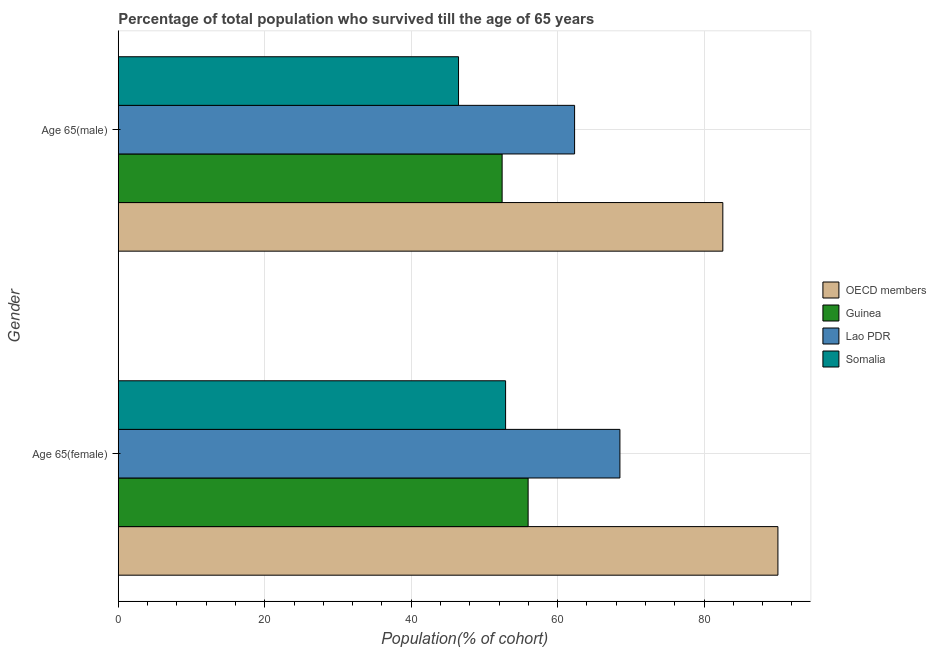How many different coloured bars are there?
Your response must be concise. 4. How many groups of bars are there?
Your response must be concise. 2. How many bars are there on the 2nd tick from the top?
Provide a short and direct response. 4. What is the label of the 2nd group of bars from the top?
Provide a succinct answer. Age 65(female). What is the percentage of male population who survived till age of 65 in Lao PDR?
Provide a succinct answer. 62.32. Across all countries, what is the maximum percentage of female population who survived till age of 65?
Offer a very short reply. 90.08. Across all countries, what is the minimum percentage of male population who survived till age of 65?
Your response must be concise. 46.47. In which country was the percentage of female population who survived till age of 65 maximum?
Offer a very short reply. OECD members. In which country was the percentage of male population who survived till age of 65 minimum?
Your response must be concise. Somalia. What is the total percentage of male population who survived till age of 65 in the graph?
Your response must be concise. 243.76. What is the difference between the percentage of female population who survived till age of 65 in Lao PDR and that in Somalia?
Provide a succinct answer. 15.61. What is the difference between the percentage of female population who survived till age of 65 in Somalia and the percentage of male population who survived till age of 65 in Guinea?
Make the answer very short. 0.47. What is the average percentage of male population who survived till age of 65 per country?
Ensure brevity in your answer.  60.94. What is the difference between the percentage of male population who survived till age of 65 and percentage of female population who survived till age of 65 in Lao PDR?
Your answer should be compact. -6.19. What is the ratio of the percentage of male population who survived till age of 65 in Lao PDR to that in Somalia?
Provide a short and direct response. 1.34. Is the percentage of male population who survived till age of 65 in OECD members less than that in Guinea?
Offer a very short reply. No. What does the 3rd bar from the top in Age 65(male) represents?
Your response must be concise. Guinea. What does the 4th bar from the bottom in Age 65(male) represents?
Offer a very short reply. Somalia. How many bars are there?
Provide a succinct answer. 8. Are all the bars in the graph horizontal?
Provide a succinct answer. Yes. What is the difference between two consecutive major ticks on the X-axis?
Your answer should be very brief. 20. Does the graph contain any zero values?
Provide a succinct answer. No. Where does the legend appear in the graph?
Offer a very short reply. Center right. How many legend labels are there?
Offer a terse response. 4. What is the title of the graph?
Provide a succinct answer. Percentage of total population who survived till the age of 65 years. Does "Monaco" appear as one of the legend labels in the graph?
Give a very brief answer. No. What is the label or title of the X-axis?
Offer a terse response. Population(% of cohort). What is the label or title of the Y-axis?
Your response must be concise. Gender. What is the Population(% of cohort) of OECD members in Age 65(female)?
Make the answer very short. 90.08. What is the Population(% of cohort) of Guinea in Age 65(female)?
Make the answer very short. 55.97. What is the Population(% of cohort) in Lao PDR in Age 65(female)?
Make the answer very short. 68.51. What is the Population(% of cohort) of Somalia in Age 65(female)?
Your answer should be very brief. 52.89. What is the Population(% of cohort) in OECD members in Age 65(male)?
Provide a short and direct response. 82.56. What is the Population(% of cohort) in Guinea in Age 65(male)?
Ensure brevity in your answer.  52.42. What is the Population(% of cohort) in Lao PDR in Age 65(male)?
Make the answer very short. 62.32. What is the Population(% of cohort) of Somalia in Age 65(male)?
Ensure brevity in your answer.  46.47. Across all Gender, what is the maximum Population(% of cohort) in OECD members?
Your answer should be very brief. 90.08. Across all Gender, what is the maximum Population(% of cohort) of Guinea?
Your answer should be compact. 55.97. Across all Gender, what is the maximum Population(% of cohort) in Lao PDR?
Offer a terse response. 68.51. Across all Gender, what is the maximum Population(% of cohort) in Somalia?
Make the answer very short. 52.89. Across all Gender, what is the minimum Population(% of cohort) in OECD members?
Provide a succinct answer. 82.56. Across all Gender, what is the minimum Population(% of cohort) in Guinea?
Keep it short and to the point. 52.42. Across all Gender, what is the minimum Population(% of cohort) in Lao PDR?
Keep it short and to the point. 62.32. Across all Gender, what is the minimum Population(% of cohort) in Somalia?
Offer a very short reply. 46.47. What is the total Population(% of cohort) of OECD members in the graph?
Give a very brief answer. 172.64. What is the total Population(% of cohort) of Guinea in the graph?
Provide a succinct answer. 108.39. What is the total Population(% of cohort) in Lao PDR in the graph?
Your answer should be compact. 130.82. What is the total Population(% of cohort) in Somalia in the graph?
Your answer should be very brief. 99.36. What is the difference between the Population(% of cohort) of OECD members in Age 65(female) and that in Age 65(male)?
Your answer should be compact. 7.52. What is the difference between the Population(% of cohort) of Guinea in Age 65(female) and that in Age 65(male)?
Ensure brevity in your answer.  3.55. What is the difference between the Population(% of cohort) of Lao PDR in Age 65(female) and that in Age 65(male)?
Your response must be concise. 6.19. What is the difference between the Population(% of cohort) of Somalia in Age 65(female) and that in Age 65(male)?
Offer a very short reply. 6.43. What is the difference between the Population(% of cohort) in OECD members in Age 65(female) and the Population(% of cohort) in Guinea in Age 65(male)?
Ensure brevity in your answer.  37.66. What is the difference between the Population(% of cohort) of OECD members in Age 65(female) and the Population(% of cohort) of Lao PDR in Age 65(male)?
Offer a terse response. 27.77. What is the difference between the Population(% of cohort) of OECD members in Age 65(female) and the Population(% of cohort) of Somalia in Age 65(male)?
Provide a short and direct response. 43.62. What is the difference between the Population(% of cohort) in Guinea in Age 65(female) and the Population(% of cohort) in Lao PDR in Age 65(male)?
Keep it short and to the point. -6.35. What is the difference between the Population(% of cohort) of Guinea in Age 65(female) and the Population(% of cohort) of Somalia in Age 65(male)?
Make the answer very short. 9.5. What is the difference between the Population(% of cohort) in Lao PDR in Age 65(female) and the Population(% of cohort) in Somalia in Age 65(male)?
Offer a very short reply. 22.04. What is the average Population(% of cohort) of OECD members per Gender?
Give a very brief answer. 86.32. What is the average Population(% of cohort) in Guinea per Gender?
Give a very brief answer. 54.19. What is the average Population(% of cohort) in Lao PDR per Gender?
Ensure brevity in your answer.  65.41. What is the average Population(% of cohort) of Somalia per Gender?
Your response must be concise. 49.68. What is the difference between the Population(% of cohort) in OECD members and Population(% of cohort) in Guinea in Age 65(female)?
Provide a short and direct response. 34.11. What is the difference between the Population(% of cohort) of OECD members and Population(% of cohort) of Lao PDR in Age 65(female)?
Ensure brevity in your answer.  21.58. What is the difference between the Population(% of cohort) in OECD members and Population(% of cohort) in Somalia in Age 65(female)?
Your response must be concise. 37.19. What is the difference between the Population(% of cohort) in Guinea and Population(% of cohort) in Lao PDR in Age 65(female)?
Your response must be concise. -12.54. What is the difference between the Population(% of cohort) of Guinea and Population(% of cohort) of Somalia in Age 65(female)?
Give a very brief answer. 3.08. What is the difference between the Population(% of cohort) of Lao PDR and Population(% of cohort) of Somalia in Age 65(female)?
Your answer should be compact. 15.61. What is the difference between the Population(% of cohort) of OECD members and Population(% of cohort) of Guinea in Age 65(male)?
Give a very brief answer. 30.14. What is the difference between the Population(% of cohort) in OECD members and Population(% of cohort) in Lao PDR in Age 65(male)?
Your answer should be compact. 20.24. What is the difference between the Population(% of cohort) of OECD members and Population(% of cohort) of Somalia in Age 65(male)?
Your answer should be compact. 36.09. What is the difference between the Population(% of cohort) of Guinea and Population(% of cohort) of Lao PDR in Age 65(male)?
Keep it short and to the point. -9.9. What is the difference between the Population(% of cohort) in Guinea and Population(% of cohort) in Somalia in Age 65(male)?
Your answer should be compact. 5.95. What is the difference between the Population(% of cohort) in Lao PDR and Population(% of cohort) in Somalia in Age 65(male)?
Provide a short and direct response. 15.85. What is the ratio of the Population(% of cohort) in OECD members in Age 65(female) to that in Age 65(male)?
Your answer should be compact. 1.09. What is the ratio of the Population(% of cohort) of Guinea in Age 65(female) to that in Age 65(male)?
Give a very brief answer. 1.07. What is the ratio of the Population(% of cohort) in Lao PDR in Age 65(female) to that in Age 65(male)?
Your answer should be compact. 1.1. What is the ratio of the Population(% of cohort) of Somalia in Age 65(female) to that in Age 65(male)?
Make the answer very short. 1.14. What is the difference between the highest and the second highest Population(% of cohort) of OECD members?
Provide a succinct answer. 7.52. What is the difference between the highest and the second highest Population(% of cohort) in Guinea?
Make the answer very short. 3.55. What is the difference between the highest and the second highest Population(% of cohort) of Lao PDR?
Your answer should be very brief. 6.19. What is the difference between the highest and the second highest Population(% of cohort) in Somalia?
Ensure brevity in your answer.  6.43. What is the difference between the highest and the lowest Population(% of cohort) of OECD members?
Keep it short and to the point. 7.52. What is the difference between the highest and the lowest Population(% of cohort) of Guinea?
Ensure brevity in your answer.  3.55. What is the difference between the highest and the lowest Population(% of cohort) of Lao PDR?
Offer a very short reply. 6.19. What is the difference between the highest and the lowest Population(% of cohort) of Somalia?
Offer a very short reply. 6.43. 